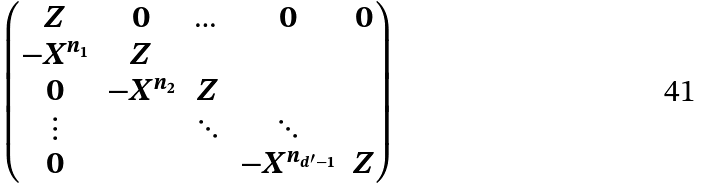Convert formula to latex. <formula><loc_0><loc_0><loc_500><loc_500>\begin{pmatrix} Z & 0 & \dots & 0 & 0 \\ - X ^ { n _ { 1 } } & Z & & & \\ 0 & - X ^ { n _ { 2 } } & Z & & \\ \vdots & & \ddots & \ddots & \\ 0 & & & - X ^ { n _ { d ^ { \prime } - 1 } } & Z \end{pmatrix}</formula> 